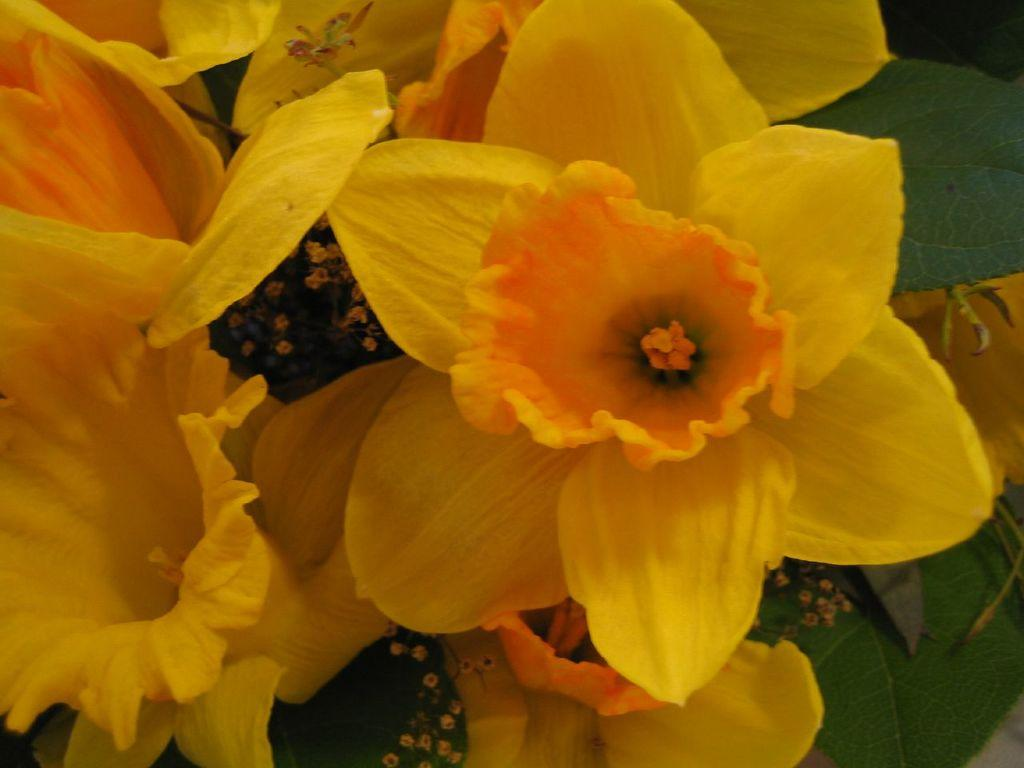What type of plant life is visible in the image? There are flowers and leaves in the image. Can you describe the flowers in the image? Unfortunately, the facts provided do not give specific details about the flowers. Are there any other elements in the image besides the flowers and leaves? The facts provided do not mention any other elements in the image. How many pigs can be seen in the image? There are no pigs present in the image; it features flowers and leaves. What type of disease is affecting the flowers in the image? The facts provided do not mention any disease affecting the flowers. 